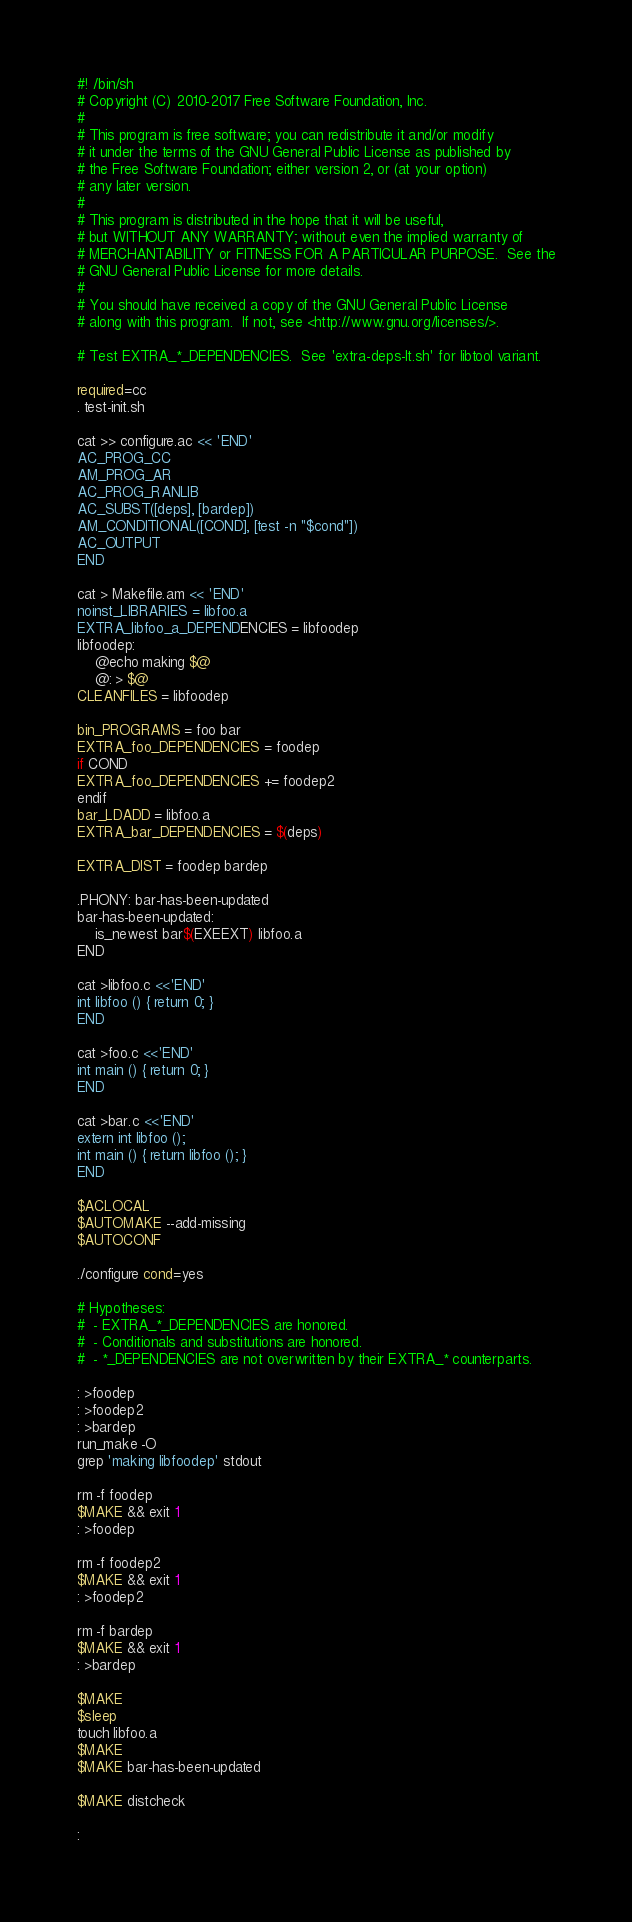Convert code to text. <code><loc_0><loc_0><loc_500><loc_500><_Bash_>#! /bin/sh
# Copyright (C) 2010-2017 Free Software Foundation, Inc.
#
# This program is free software; you can redistribute it and/or modify
# it under the terms of the GNU General Public License as published by
# the Free Software Foundation; either version 2, or (at your option)
# any later version.
#
# This program is distributed in the hope that it will be useful,
# but WITHOUT ANY WARRANTY; without even the implied warranty of
# MERCHANTABILITY or FITNESS FOR A PARTICULAR PURPOSE.  See the
# GNU General Public License for more details.
#
# You should have received a copy of the GNU General Public License
# along with this program.  If not, see <http://www.gnu.org/licenses/>.

# Test EXTRA_*_DEPENDENCIES.  See 'extra-deps-lt.sh' for libtool variant.

required=cc
. test-init.sh

cat >> configure.ac << 'END'
AC_PROG_CC
AM_PROG_AR
AC_PROG_RANLIB
AC_SUBST([deps], [bardep])
AM_CONDITIONAL([COND], [test -n "$cond"])
AC_OUTPUT
END

cat > Makefile.am << 'END'
noinst_LIBRARIES = libfoo.a
EXTRA_libfoo_a_DEPENDENCIES = libfoodep
libfoodep:
	@echo making $@
	@: > $@
CLEANFILES = libfoodep

bin_PROGRAMS = foo bar
EXTRA_foo_DEPENDENCIES = foodep
if COND
EXTRA_foo_DEPENDENCIES += foodep2
endif
bar_LDADD = libfoo.a
EXTRA_bar_DEPENDENCIES = $(deps)

EXTRA_DIST = foodep bardep

.PHONY: bar-has-been-updated
bar-has-been-updated:
	is_newest bar$(EXEEXT) libfoo.a
END

cat >libfoo.c <<'END'
int libfoo () { return 0; }
END

cat >foo.c <<'END'
int main () { return 0; }
END

cat >bar.c <<'END'
extern int libfoo ();
int main () { return libfoo (); }
END

$ACLOCAL
$AUTOMAKE --add-missing
$AUTOCONF

./configure cond=yes

# Hypotheses:
#  - EXTRA_*_DEPENDENCIES are honored.
#  - Conditionals and substitutions are honored.
#  - *_DEPENDENCIES are not overwritten by their EXTRA_* counterparts.

: >foodep
: >foodep2
: >bardep
run_make -O
grep 'making libfoodep' stdout

rm -f foodep
$MAKE && exit 1
: >foodep

rm -f foodep2
$MAKE && exit 1
: >foodep2

rm -f bardep
$MAKE && exit 1
: >bardep

$MAKE
$sleep
touch libfoo.a
$MAKE
$MAKE bar-has-been-updated

$MAKE distcheck

:
</code> 